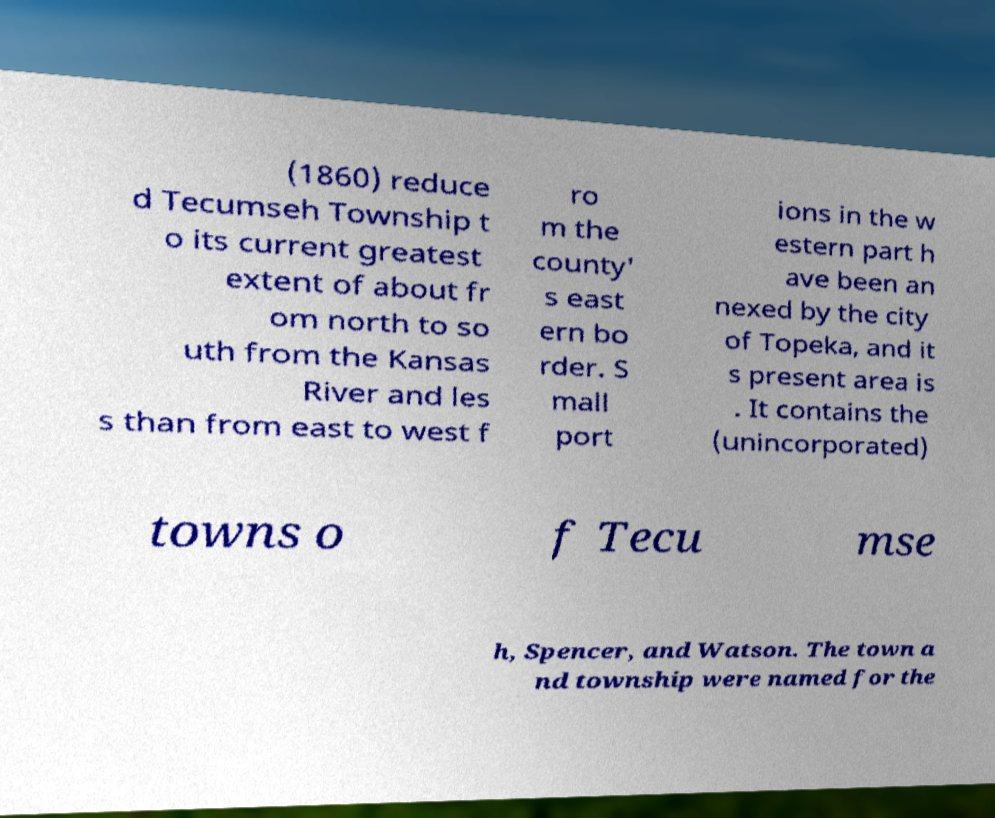Can you accurately transcribe the text from the provided image for me? (1860) reduce d Tecumseh Township t o its current greatest extent of about fr om north to so uth from the Kansas River and les s than from east to west f ro m the county' s east ern bo rder. S mall port ions in the w estern part h ave been an nexed by the city of Topeka, and it s present area is . It contains the (unincorporated) towns o f Tecu mse h, Spencer, and Watson. The town a nd township were named for the 